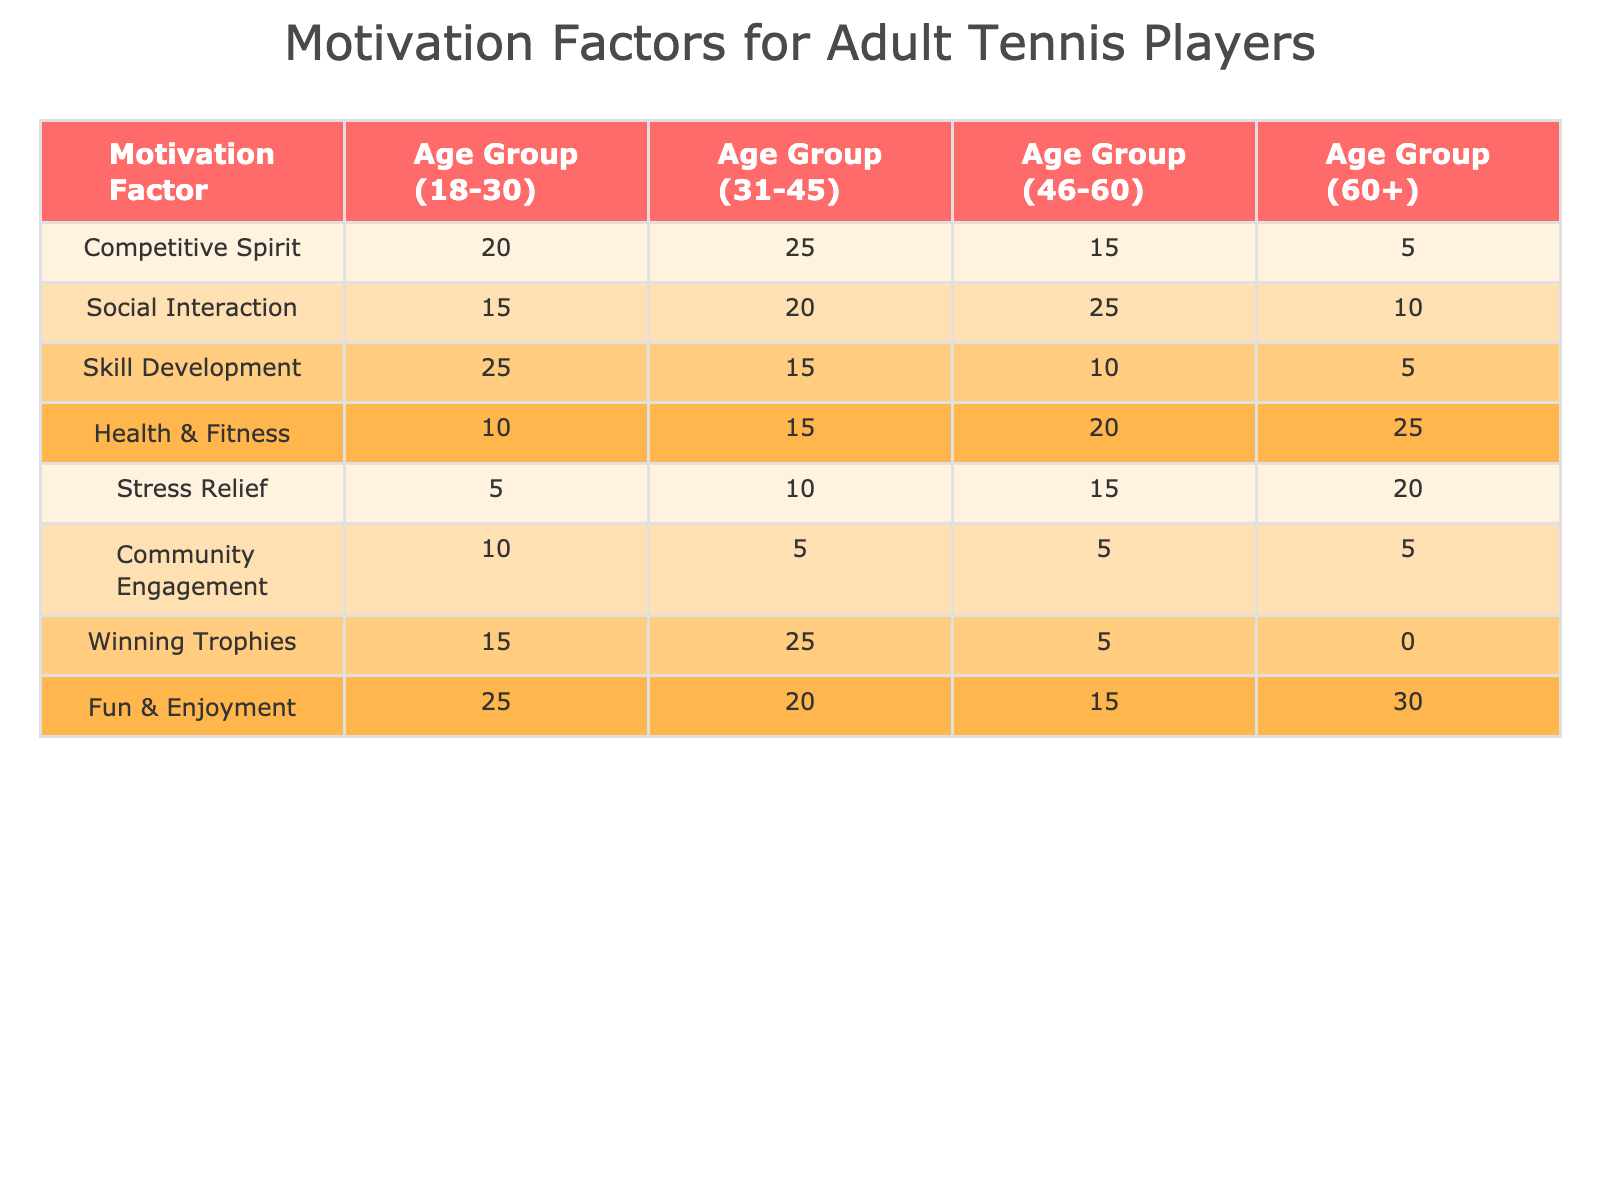What is the motivation factor with the highest participation in the age group 18-30? In the age group 18-30, the highest participation is for the motivation factor "Fun & Enjoyment" with a value of 25.
Answer: Fun & Enjoyment How many players in the age group 31-45 are motivated by Competitive Spirit? The number of players in the age group 31-45 who are motivated by Competitive Spirit is 25, as directly taken from the table.
Answer: 25 Which motivation factor has the lowest participation in the age group 60+? In the age group 60+, the motivation factor with the lowest participation is "Winning Trophies," which has a value of 0.
Answer: Winning Trophies What is the total participation for Health & Fitness across all age groups? We add up the values for the Health & Fitness motivation factor: 10 + 15 + 20 + 25 = 70. Thus, the total participation is 70.
Answer: 70 Is Social Interaction a motivating factor for players aged 46-60? Yes, the table shows that the number of players in the age group 46-60 motivated by Social Interaction is 25, which indicates its relevance.
Answer: Yes What is the difference in participation between Competitive Spirit and Fun & Enjoyment in the age group 31-45? The participation for Competitive Spirit in this age group is 25, while for Fun & Enjoyment, it is 20. The difference is 25 - 20 = 5.
Answer: 5 Which age group demonstrates the most balance in motivation factors between Competitive Spirit and Skill Development? In the age group 31-45, the difference between the values is the smallest: Competitive Spirit (25) and Skill Development (15). The difference is 25 - 15 = 10, which is lower than in other groups.
Answer: Age group 31-45 What is the average participation for each motivation factor? To calculate the average, we sum the participation of each factor and divide by the number of age groups. For example, for Fun & Enjoyment: (25 + 20 + 15 + 30) / 4 = 22.5. The average for other factors is calculated similarly.
Answer: Varies by factor; e.g., Fun & Enjoyment average is 22.5 Who shows more interest in winning trophies, the 31-45 age group or the 46-60 age group? The 31-45 age group shows more interest in winning trophies with a count of 25, compared to 5 in the 46-60 age group, indicating higher motivation among the younger participants.
Answer: 31-45 age group 